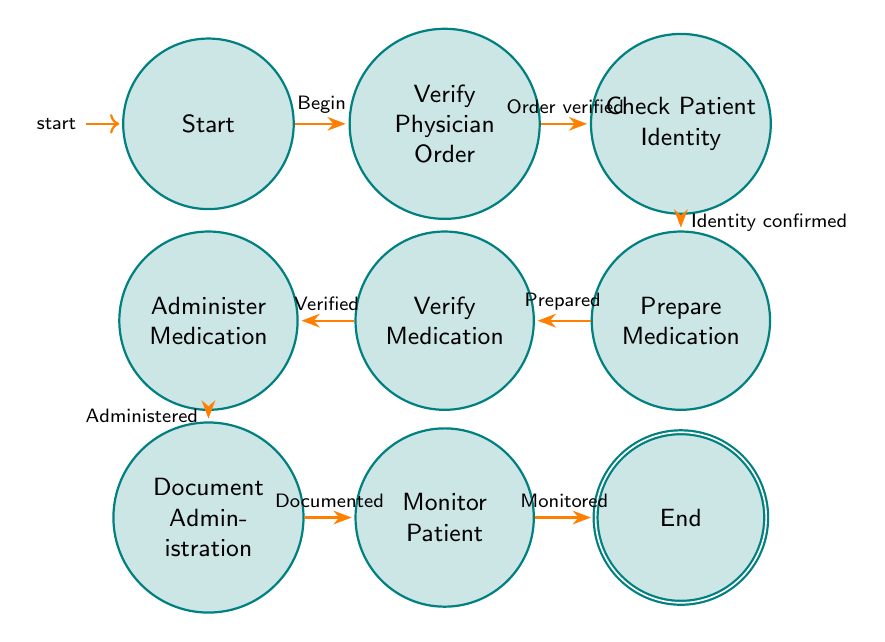What is the starting state of the diagram? The starting state is indicated as "Start" in the diagram, which is where the medication administration process begins.
Answer: Start How many states are present in the diagram? By counting the nodes in the diagram, we identify a total of 9 distinct states involved in the medication administration process.
Answer: 9 What is the final state of the diagram? The diagram shows that the final state after all the transitions is "End", which indicates the completion of the medication administration process.
Answer: End What comes after "Document Administration"? Following "Document Administration" in the diagram, the next state that occurs is "Monitor Patient", indicating the nurse's responsibility to observe the patient post-administration.
Answer: Monitor Patient Which state leads to "Verify Medication"? "Prepare Medication" directly transitions to "Verify Medication" in the process depicted by the diagram, meaning the medication is first prepared before it can be verified.
Answer: Prepare Medication How many transitions are there in total? By counting each directed edge between states, there are 8 transitions that illustrate the flow of actions taken by the nurse during medication administration.
Answer: 8 What must be done before administering medication? Before "Administer Medication", the nurse must first transition through "Verify Medication" to ensure that the prepared medication matches the physician's order.
Answer: Verify Medication Which state contains a check for patient identity? The state where the nurse checks for patient identity is labeled as "Check Patient Identity" in the diagram, indicating a critical verification step.
Answer: Check Patient Identity What action must occur after verification of the physician's order? After "Verify Physician Order" is completed, the next required action is to "Check Patient Identity", emphasizing the importance of confirming who is receiving the medication.
Answer: Check Patient Identity 